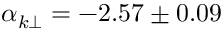<formula> <loc_0><loc_0><loc_500><loc_500>\alpha _ { k \perp } = - 2 . 5 7 \pm 0 . 0 9</formula> 